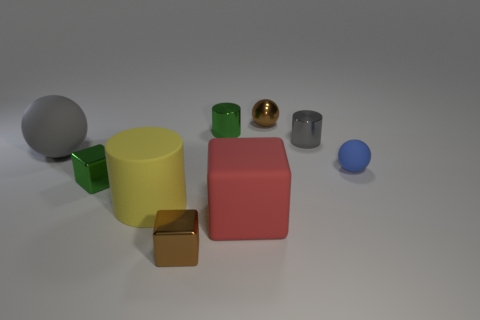What number of rubber things are the same size as the green metallic block?
Offer a terse response. 1. What number of blue matte objects are in front of the brown object that is in front of the green metal block?
Provide a succinct answer. 0. What size is the ball that is right of the big yellow cylinder and in front of the metallic ball?
Offer a terse response. Small. Are there more small green metal objects than tiny red metal cylinders?
Make the answer very short. Yes. Is there a large cylinder of the same color as the big rubber cube?
Keep it short and to the point. No. There is a green metal object that is in front of the blue thing; is its size the same as the red rubber object?
Make the answer very short. No. Are there fewer yellow cylinders than large green shiny cubes?
Your answer should be very brief. No. Is there a large red cube that has the same material as the yellow cylinder?
Your answer should be compact. Yes. There is a small metal object that is on the left side of the brown cube; what shape is it?
Your response must be concise. Cube. There is a small block in front of the large rubber block; is it the same color as the metal sphere?
Ensure brevity in your answer.  Yes. 